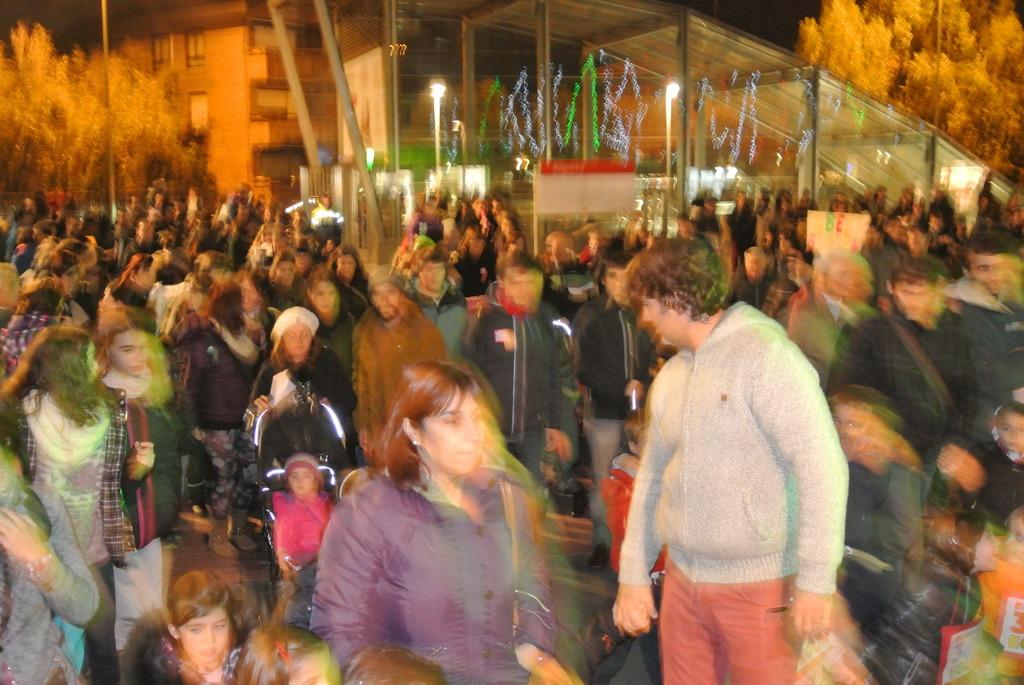How many people are in the image? There is a group of people in the image, but the exact number is not specified. What can be seen in the image besides the people? There are poles, lights, buildings, trees, and unspecified objects in the image. What is the color of the background in the image? The background of the image is dark. What type of tax is being discussed by the people in the image? There is no indication in the image that the people are discussing any type of tax. What is located on the back of the people in the image? The image does not provide enough detail to determine what might be located on the back of the people. 